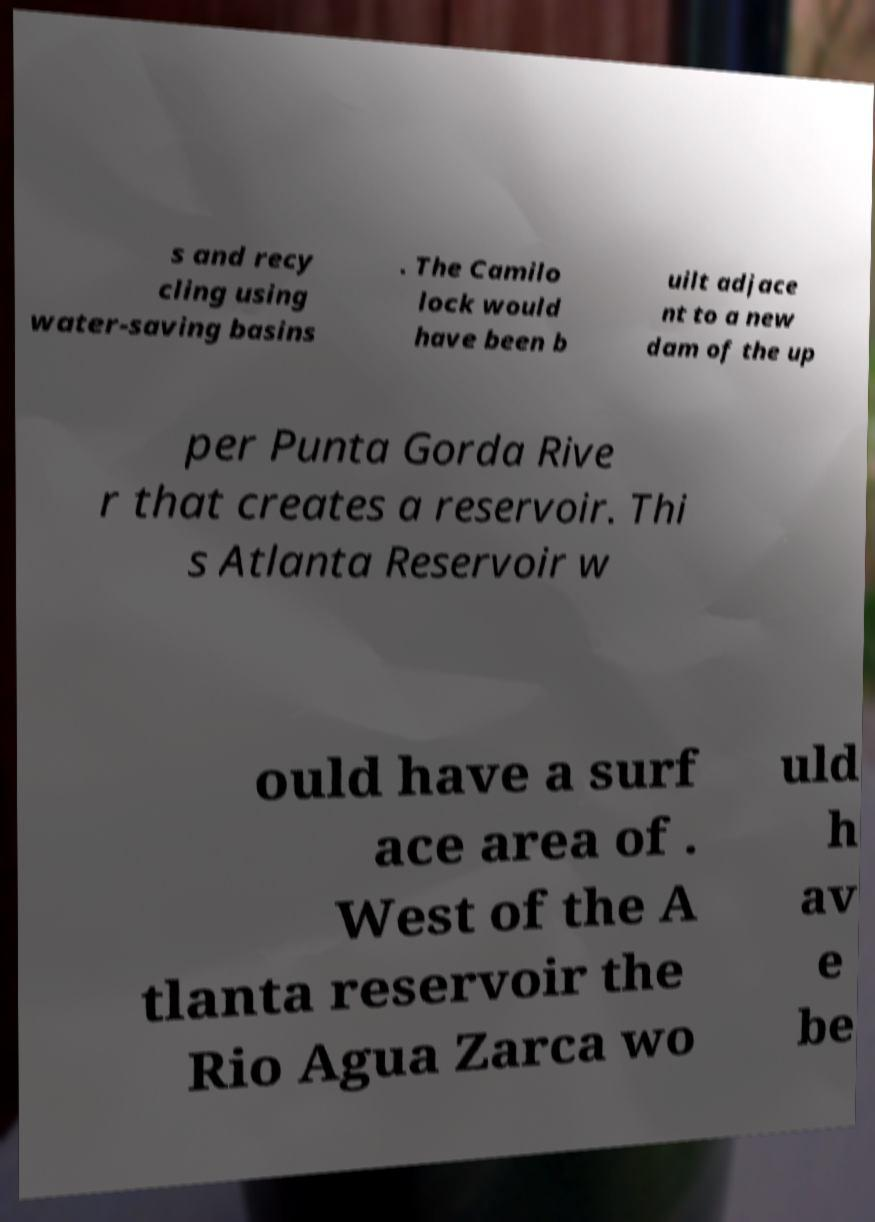I need the written content from this picture converted into text. Can you do that? s and recy cling using water-saving basins . The Camilo lock would have been b uilt adjace nt to a new dam of the up per Punta Gorda Rive r that creates a reservoir. Thi s Atlanta Reservoir w ould have a surf ace area of . West of the A tlanta reservoir the Rio Agua Zarca wo uld h av e be 